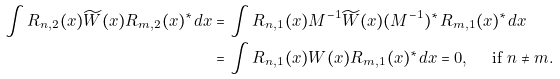Convert formula to latex. <formula><loc_0><loc_0><loc_500><loc_500>\int R _ { n , 2 } ( x ) \widetilde { W } ( x ) R _ { m , 2 } ( x ) ^ { * } d x & = \int R _ { n , 1 } ( x ) M ^ { - 1 } \widetilde { W } ( x ) ( M ^ { - 1 } ) ^ { * } R _ { m , 1 } ( x ) ^ { * } d x \\ & = \int R _ { n , 1 } ( x ) W ( x ) R _ { m , 1 } ( x ) ^ { * } d x = 0 , \quad \text { if } n \neq m .</formula> 